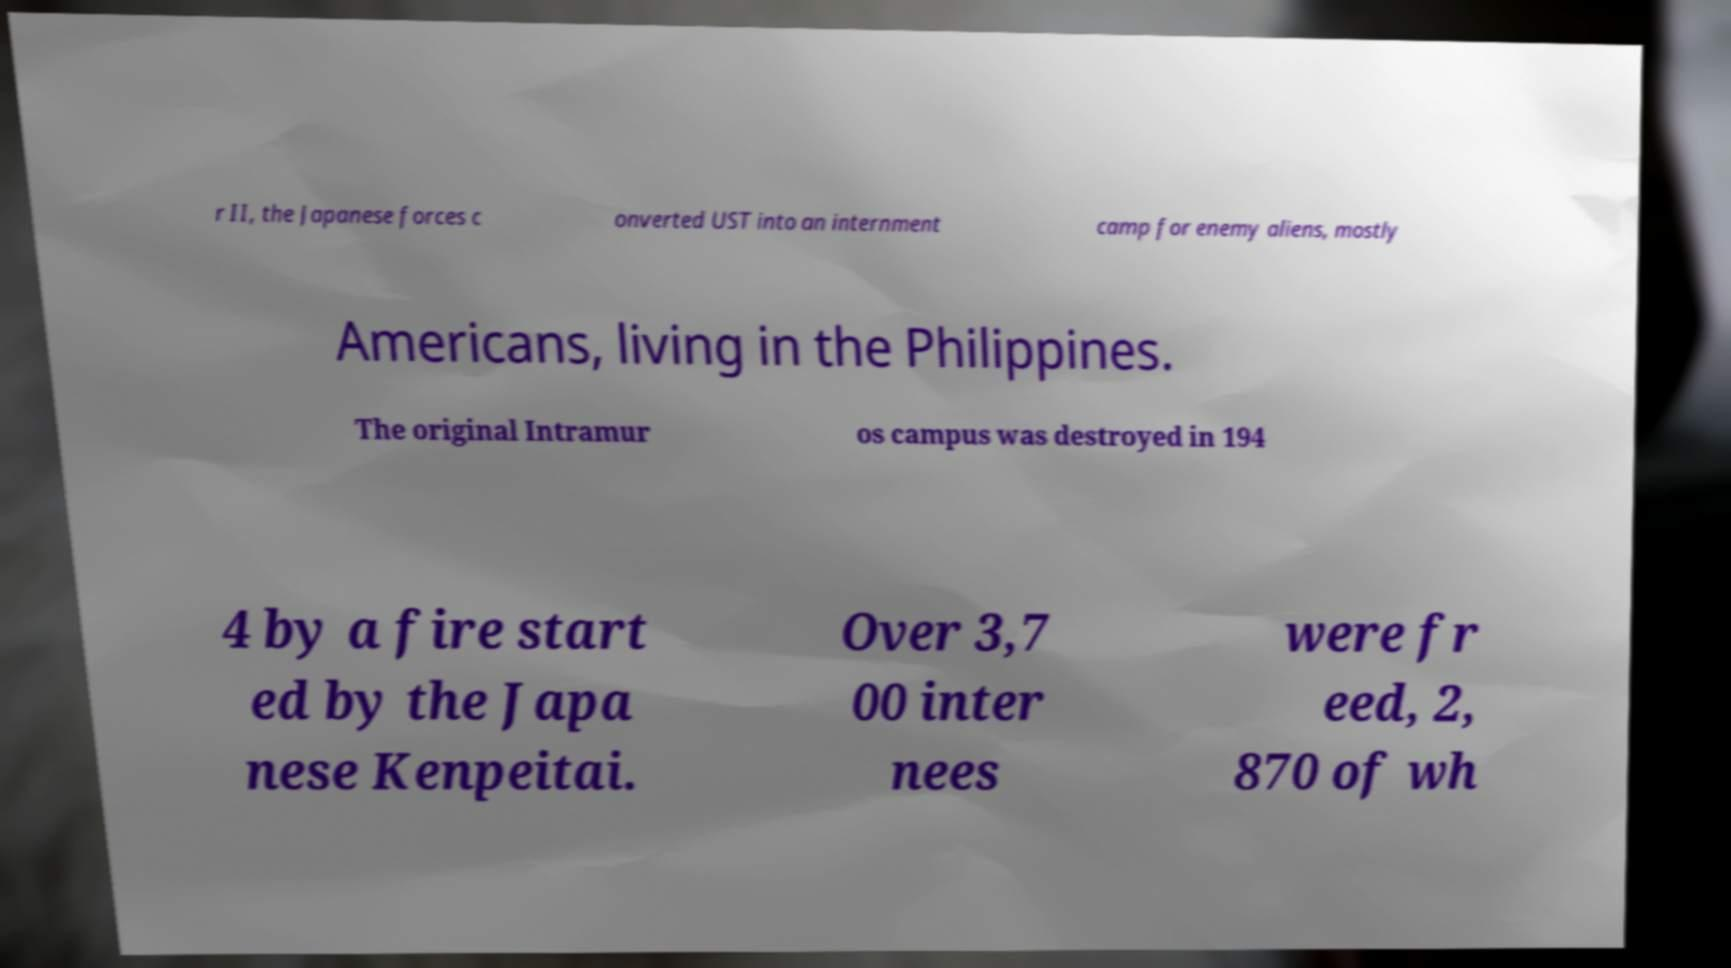Please read and relay the text visible in this image. What does it say? r II, the Japanese forces c onverted UST into an internment camp for enemy aliens, mostly Americans, living in the Philippines. The original Intramur os campus was destroyed in 194 4 by a fire start ed by the Japa nese Kenpeitai. Over 3,7 00 inter nees were fr eed, 2, 870 of wh 